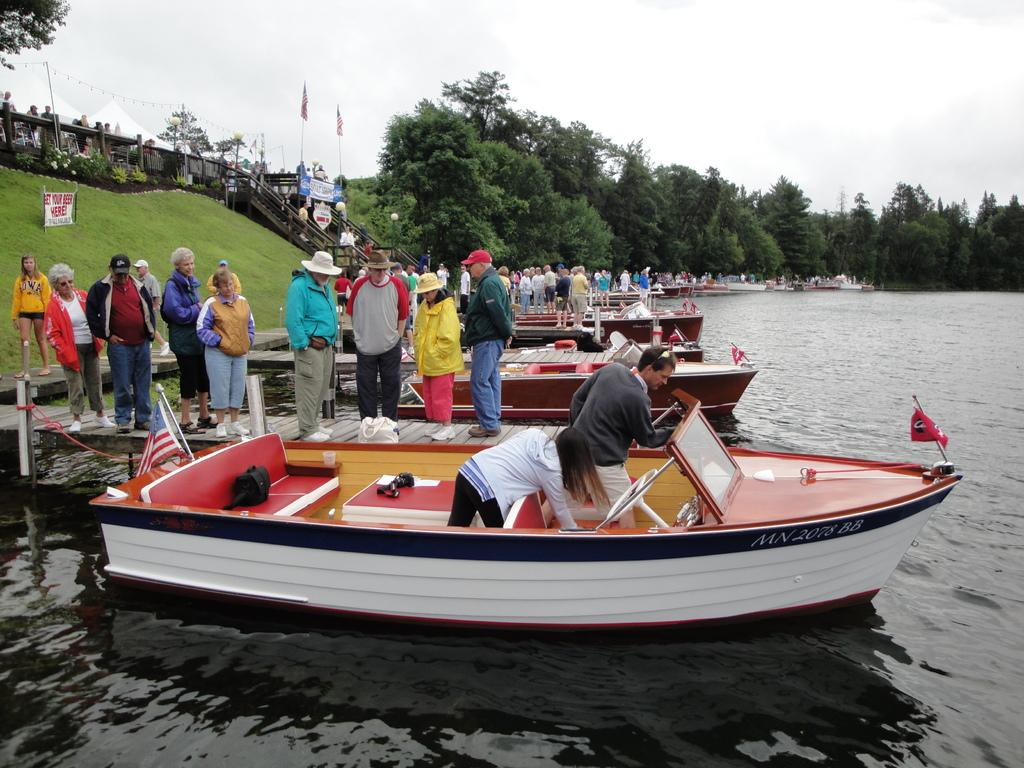<image>
Give a short and clear explanation of the subsequent image. On the hill above the water is a sign that says GET YOUR BEER HERE! 